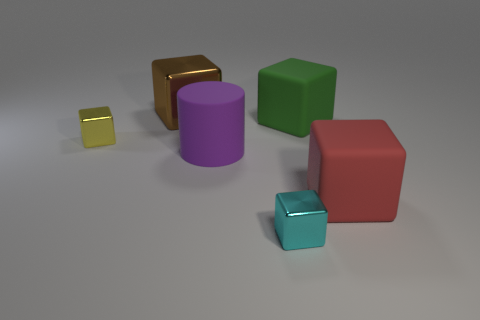Are there any objects that stand out due to their size? Yes, the large red cube stands out because it is visibly larger than the other objects in the image. 